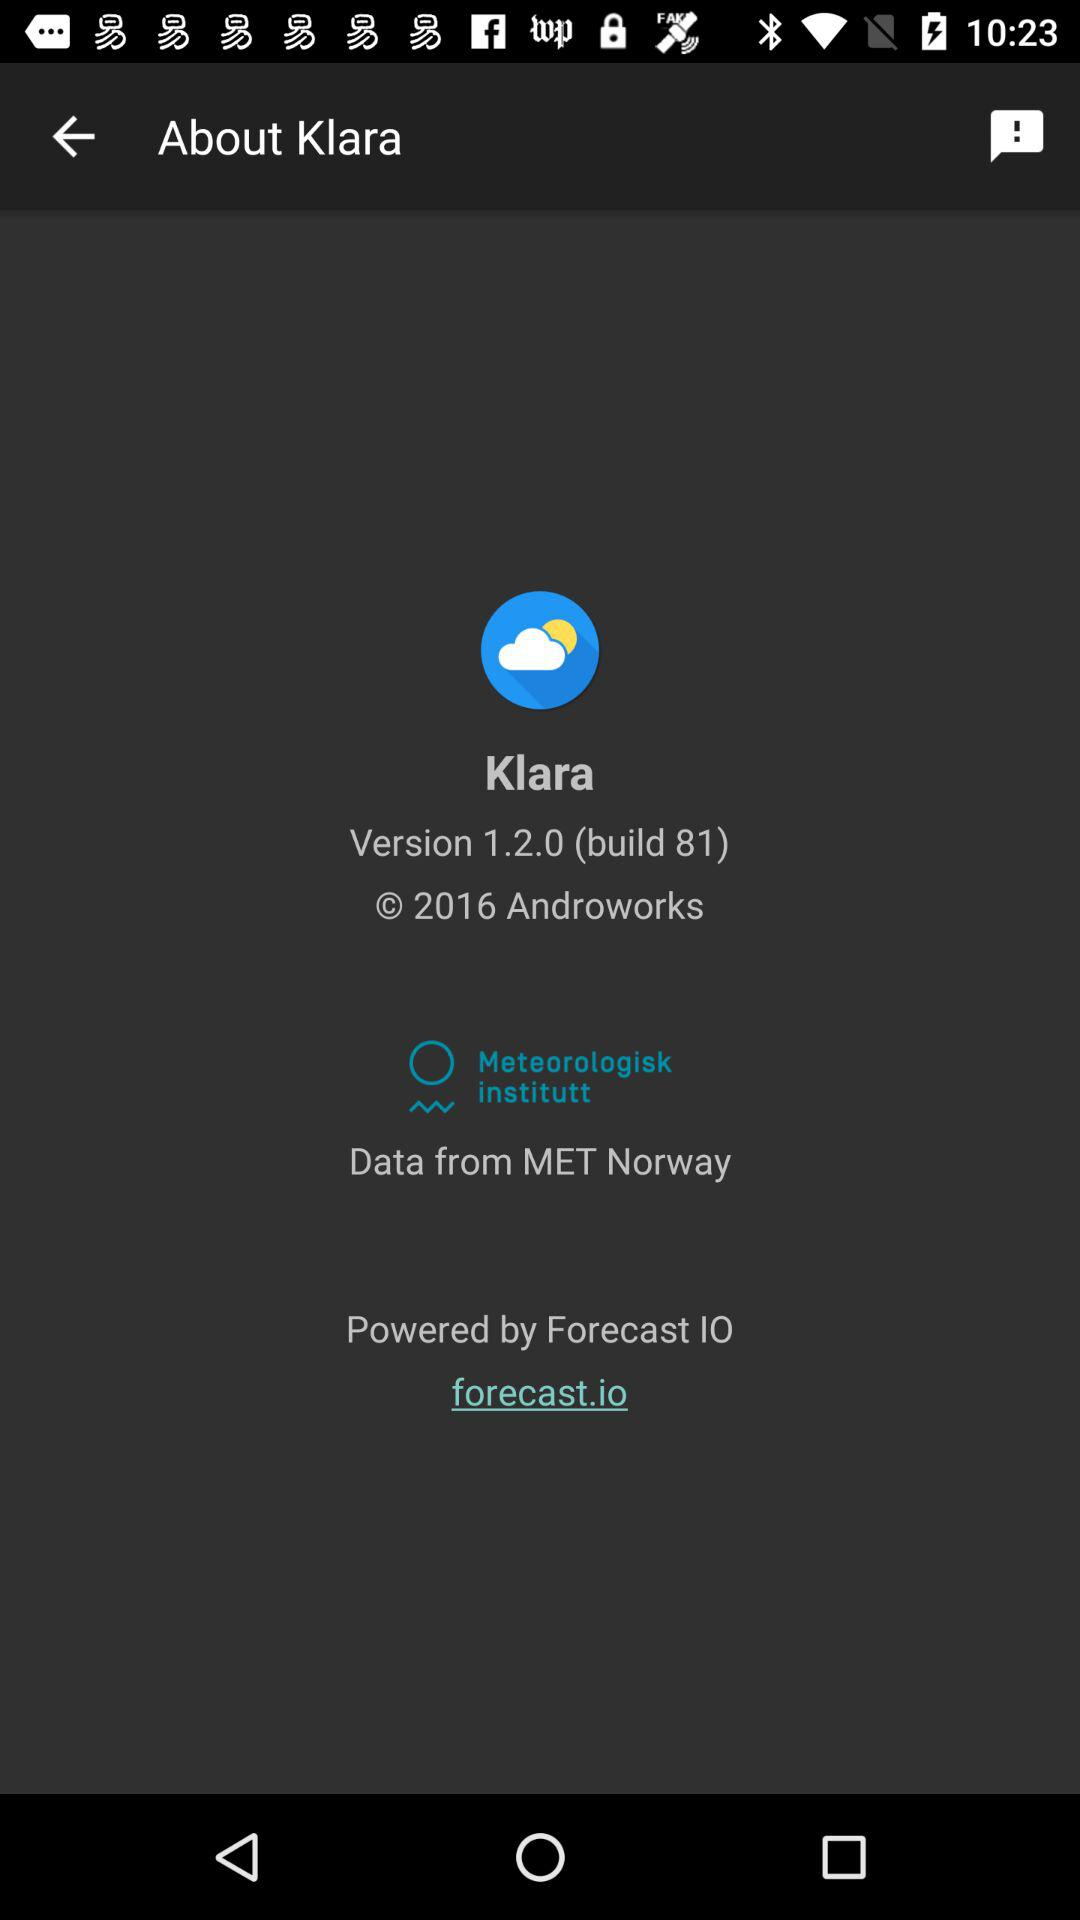What is the name of the application? The name of the application is "Klara". 